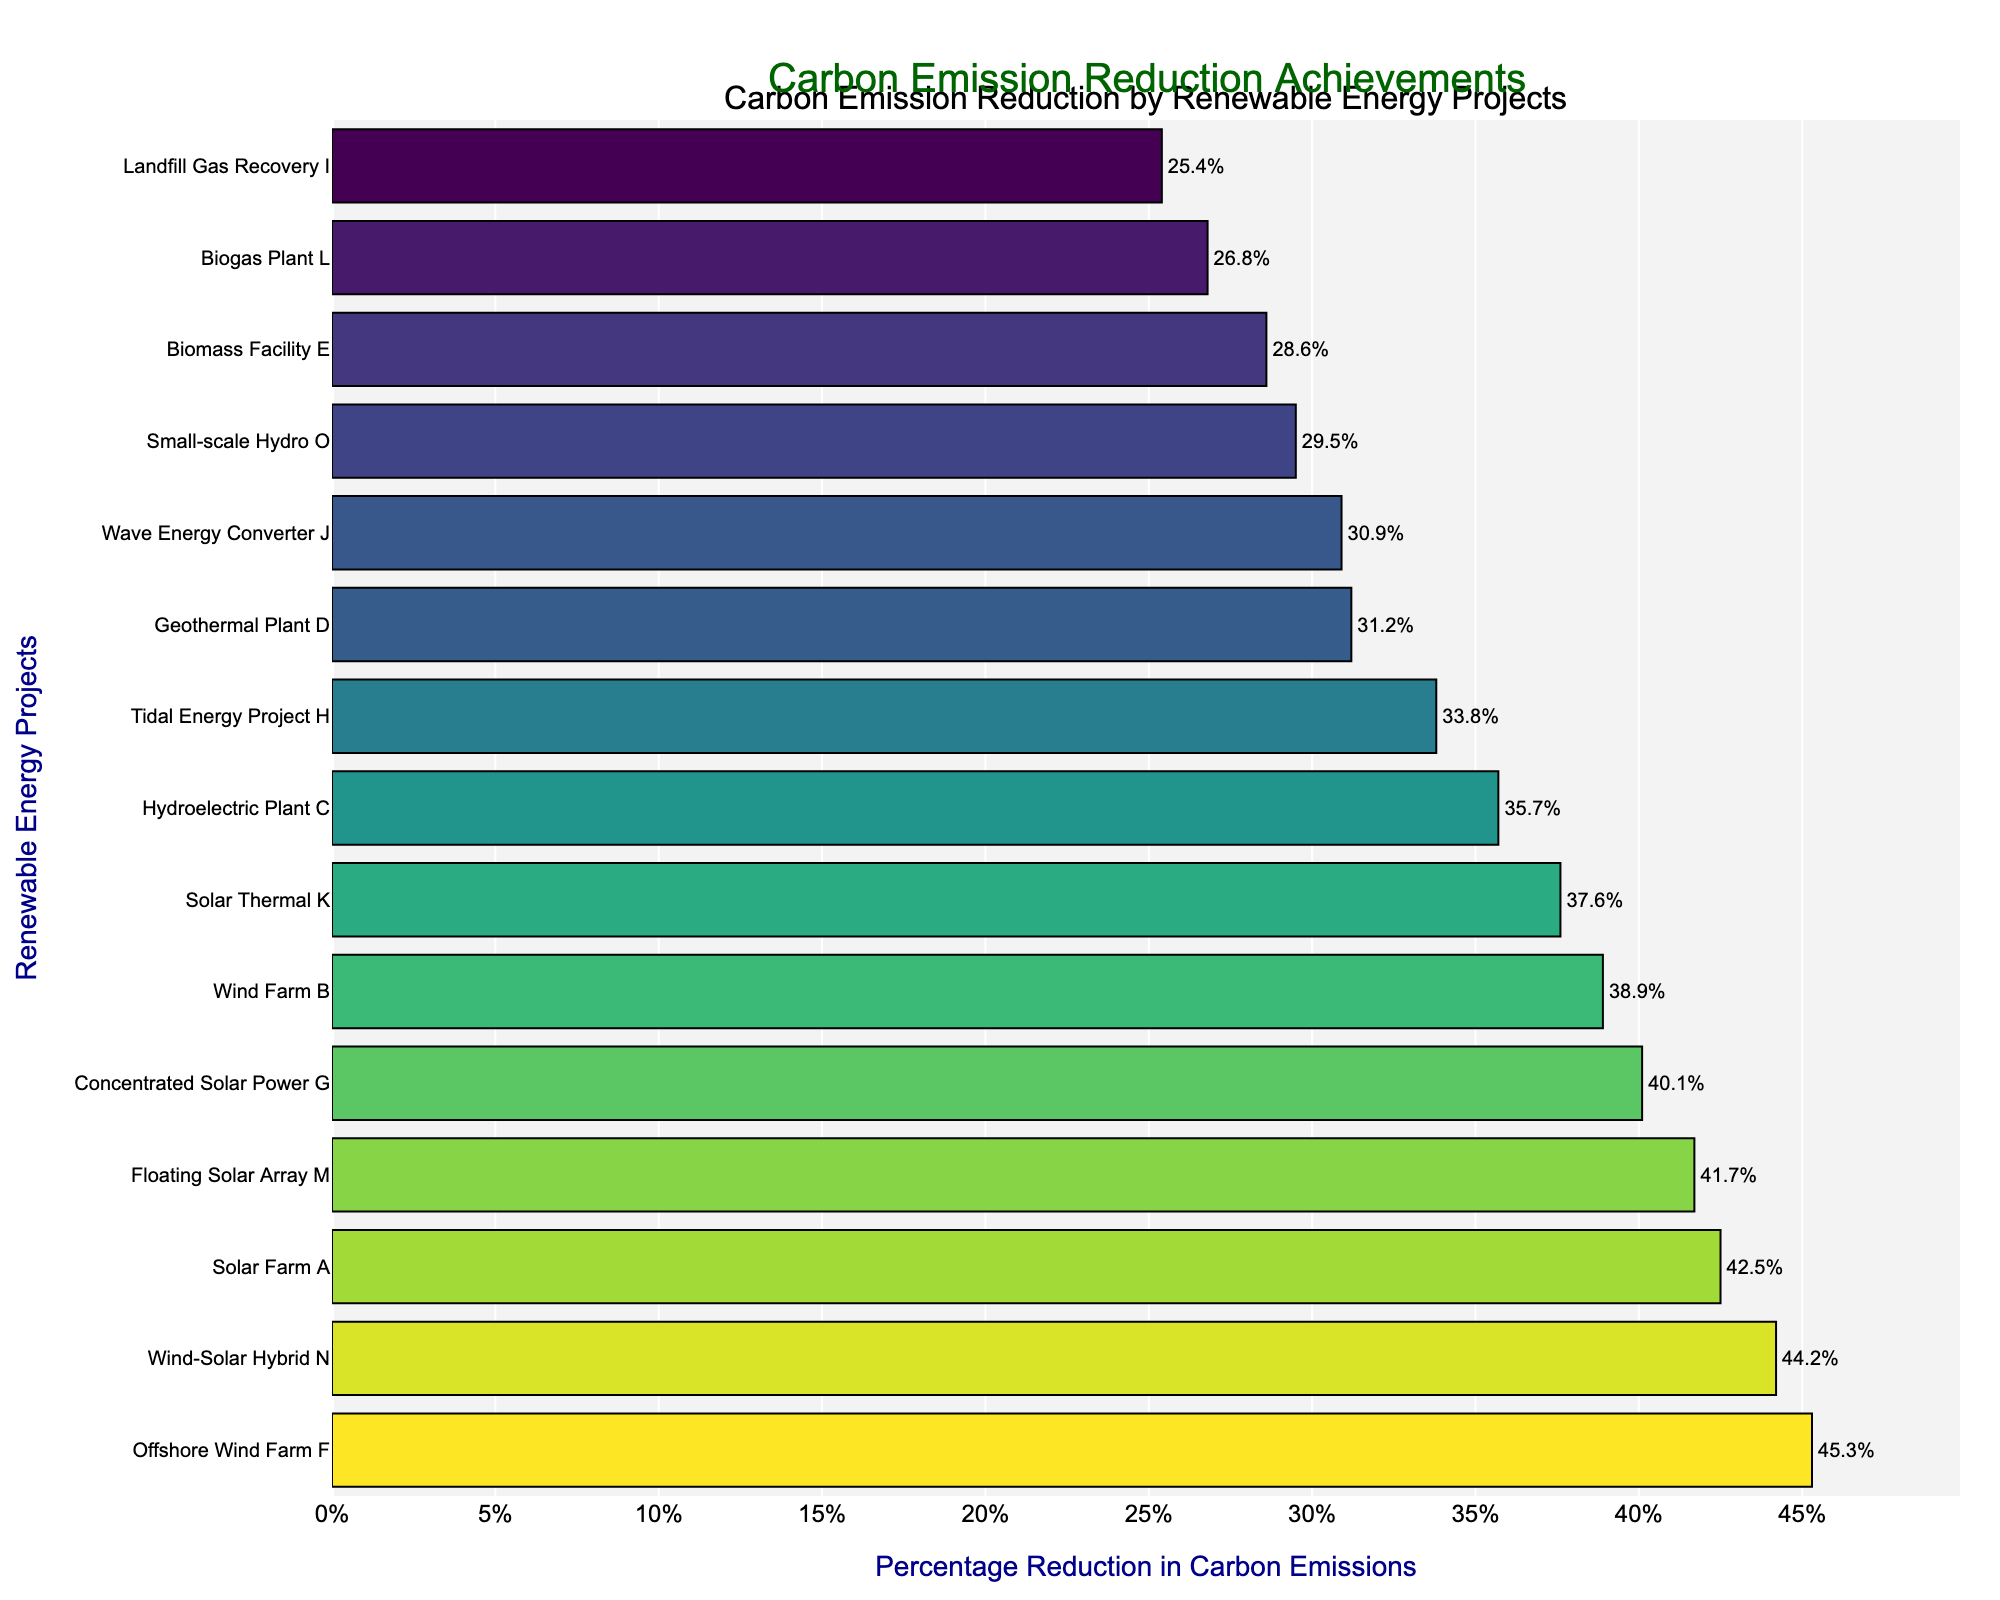Which project has the highest percentage reduction in carbon emissions? Observing the figure, the Offshore Wind Farm F has the longest bar among all projects, indicating the highest percentage reduction.
Answer: Offshore Wind Farm F Which project has the lowest percentage reduction in carbon emissions? The shortest bar on the chart corresponds to the Landfill Gas Recovery I project.
Answer: Landfill Gas Recovery I What is the combined percentage reduction in carbon emissions for Solar Farm A and Wind-Solar Hybrid N? Add the percentage reductions for Solar Farm A (42.5%) and Wind-Solar Hybrid N (44.2%). 42.5 + 44.2 = 86.7
Answer: 86.7% How does the carbon emission reduction of the Biomass Facility E compare to that of Biogas Plant L? The bar for Biomass Facility E (28.6%) is slightly higher than that of Biogas Plant L (26.8%), indicating a greater percentage reduction.
Answer: Biomass Facility E is higher Which project among Tidal Energy Project H and Wave Energy Converter J has a higher percentage reduction in carbon emissions? Comparing the lengths of the bars, Tidal Energy Project H (33.8%) has a higher percentage reduction than Wave Energy Converter J (30.9%).
Answer: Tidal Energy Project H Which project achieved closer to a 40% reduction: Solar Thermal K or Geothermal Plant D? To answer this, compare the bars for Solar Thermal K (37.6%) and Geothermal Plant D (31.2%). Solar Thermal K is closer to 40%.
Answer: Solar Thermal K What is the average percentage reduction achieved by the top three projects? Identify the top three projects (Offshore Wind Farm F 45.3%, Wind-Solar Hybrid N 44.2%, Solar Farm A 42.5%), add their percentages together, and divide by 3. (45.3 + 44.2 + 42.5) / 3 = 44
Answer: 44% How much higher is the percentage reduction of Concentrated Solar Power G compared to that of the Small-scale Hydro O? Subtract the percentage reduction for Small-scale Hydro O (29.5%) from that of Concentrated Solar Power G (40.1%). 40.1 - 29.5 = 10.6
Answer: 10.6% Is the percentage reduction in carbon emissions achieved by Floating Solar Array M greater than the average percentage reduction of all projects? First, calculate the average of all projects by summing their percentages and dividing by the number of projects. Then compare this value to Floating Solar Array M's reduction (41.7%). Sum of all percentages = 564.2, number of projects = 15, average = 564.2/15 ≈ 37.61%. 41.7 > 37.61
Answer: Yes 